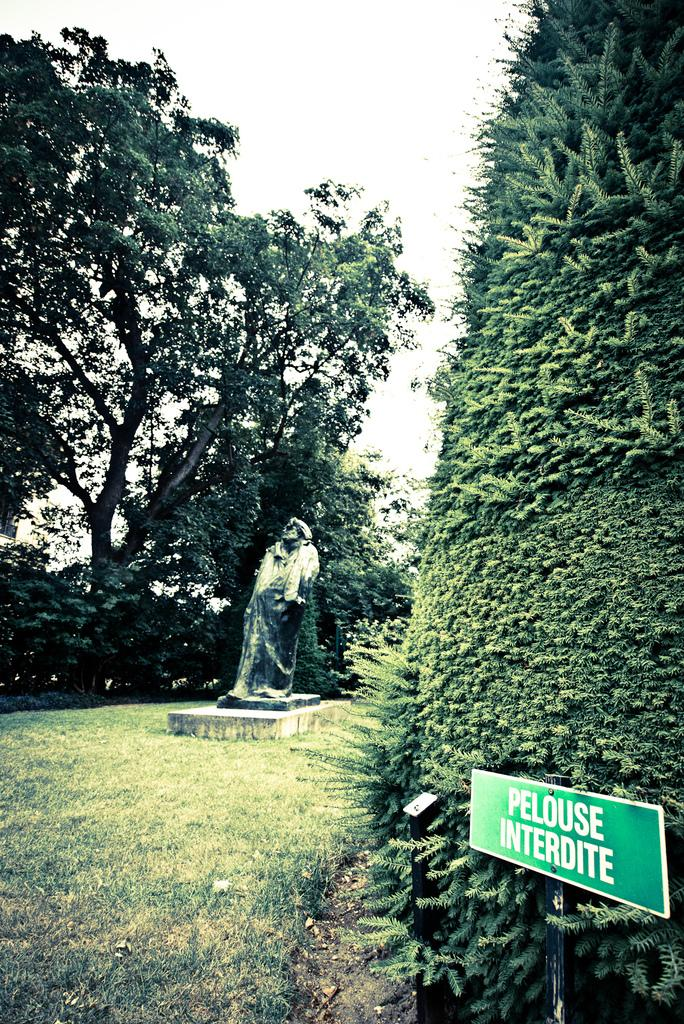What type of natural elements can be seen in the image? There are trees and plants in the image. What is the main object in the middle of the image? There is a sculpture in the middle of the image. What can be found on the display board in the image? The display board has text in the image. What is visible in the background of the image? The sky is visible in the image. How many dogs are playing with the flame in the image? There are no dogs or flames present in the image; it features trees, plants, a sculpture, a display board, and the sky. 